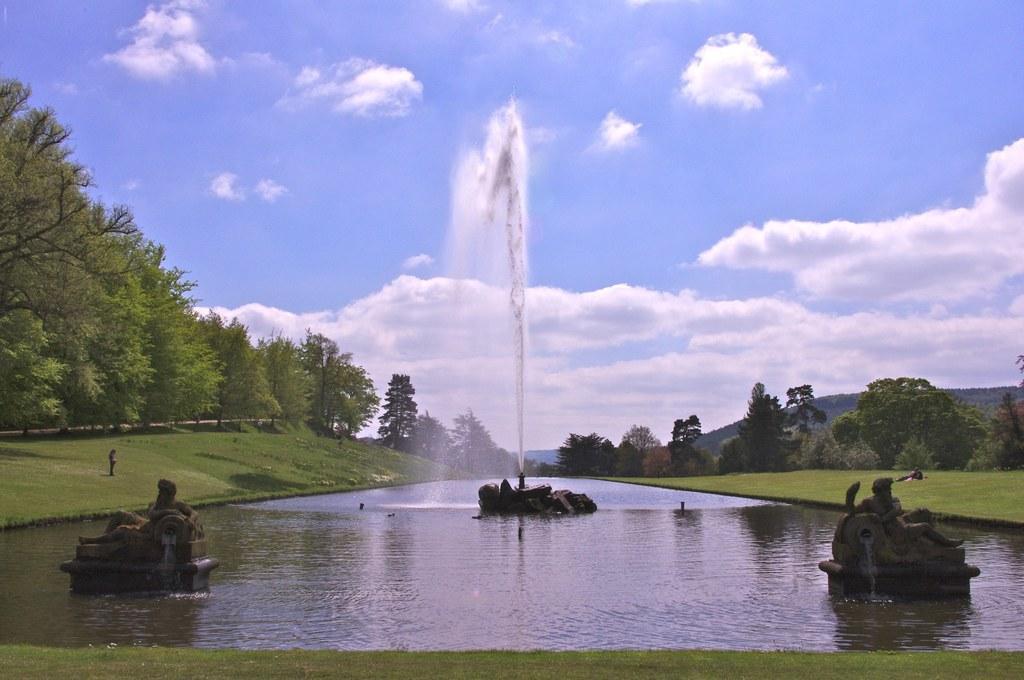In one or two sentences, can you explain what this image depicts? In the picture I can see a water fountain. I can also see statues in the water. In the background I can see the grass, trees, the sky and some other objects. 